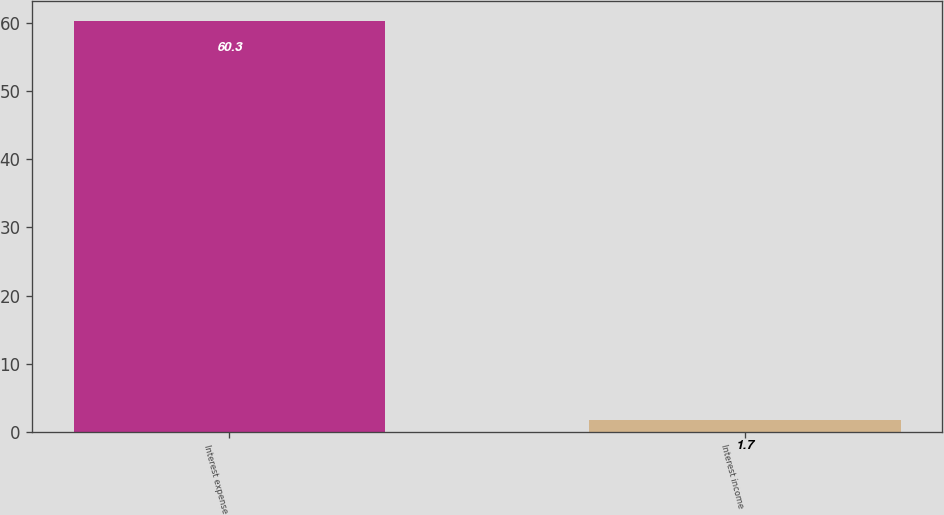Convert chart. <chart><loc_0><loc_0><loc_500><loc_500><bar_chart><fcel>Interest expense<fcel>Interest income<nl><fcel>60.3<fcel>1.7<nl></chart> 